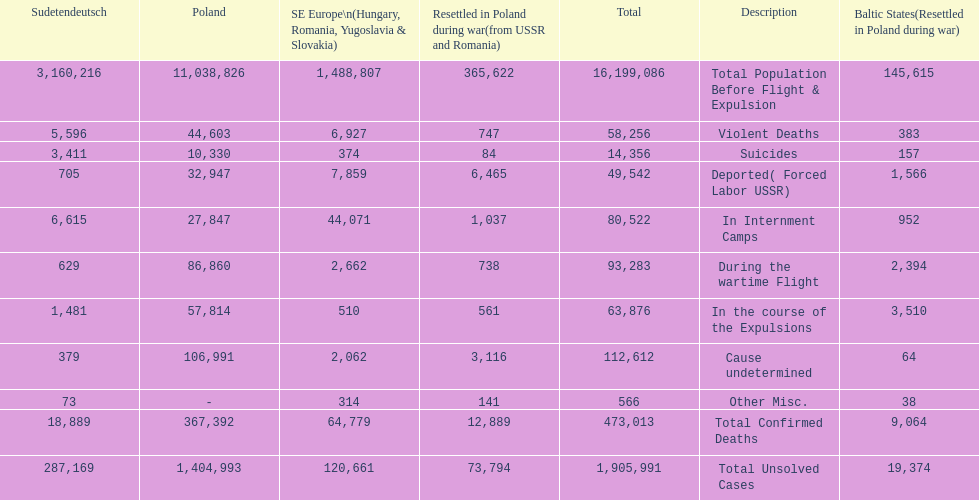How many causes were responsible for more than 50,000 confirmed deaths? 5. 